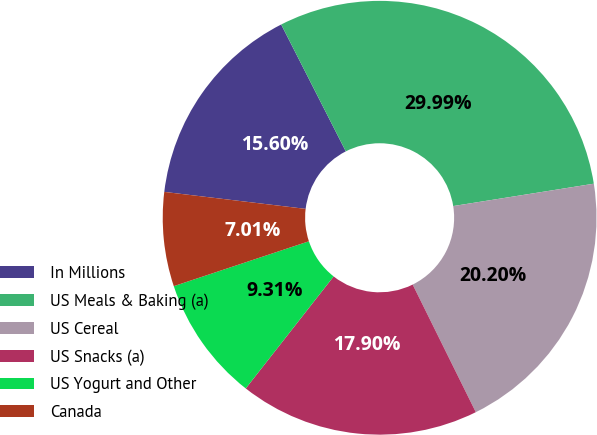Convert chart to OTSL. <chart><loc_0><loc_0><loc_500><loc_500><pie_chart><fcel>In Millions<fcel>US Meals & Baking (a)<fcel>US Cereal<fcel>US Snacks (a)<fcel>US Yogurt and Other<fcel>Canada<nl><fcel>15.6%<fcel>29.99%<fcel>20.2%<fcel>17.9%<fcel>9.31%<fcel>7.01%<nl></chart> 